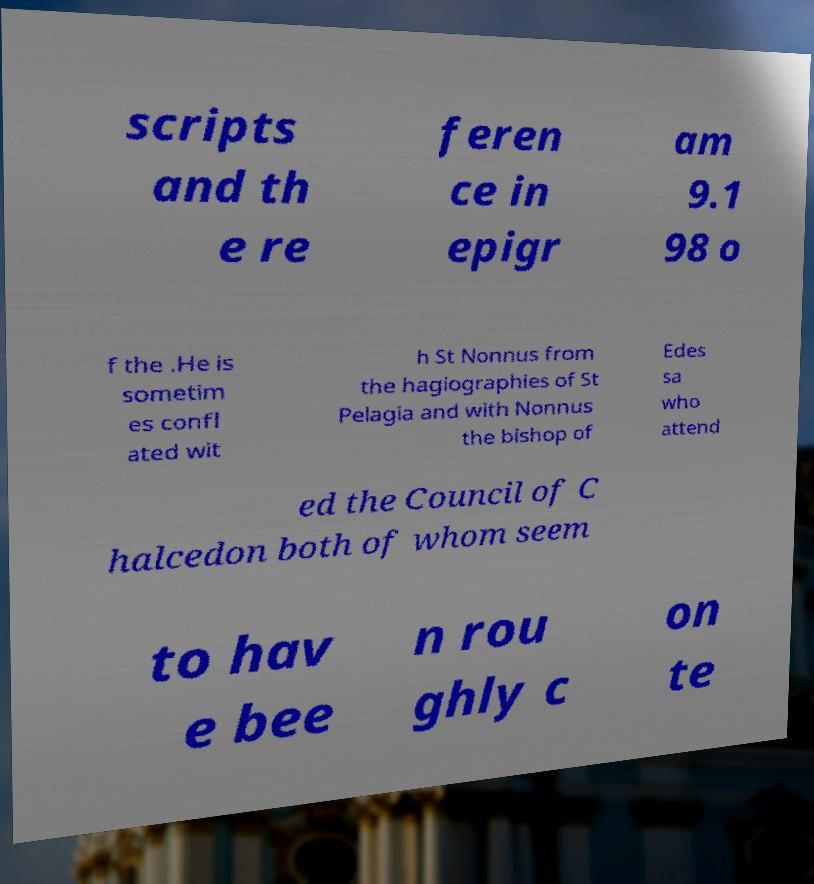What messages or text are displayed in this image? I need them in a readable, typed format. scripts and th e re feren ce in epigr am 9.1 98 o f the .He is sometim es confl ated wit h St Nonnus from the hagiographies of St Pelagia and with Nonnus the bishop of Edes sa who attend ed the Council of C halcedon both of whom seem to hav e bee n rou ghly c on te 